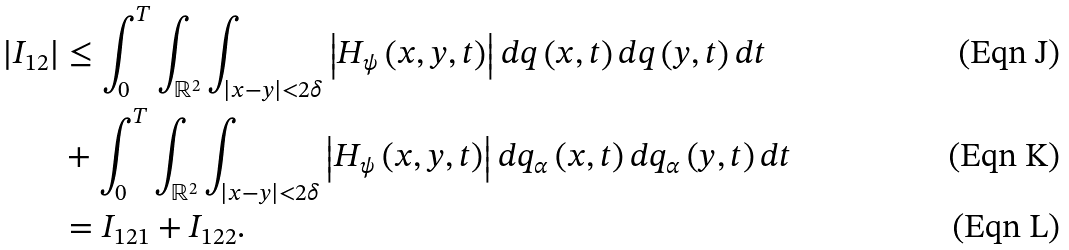Convert formula to latex. <formula><loc_0><loc_0><loc_500><loc_500>\left | I _ { 1 2 } \right | & \leq \int _ { 0 } ^ { T } \int _ { \mathbb { R } ^ { 2 } } \int _ { \left | x - y \right | < 2 \delta } \left | H _ { \psi } \left ( x , y , t \right ) \right | d q \left ( x , t \right ) d q \left ( y , t \right ) d t \\ & + \int _ { 0 } ^ { T } \int _ { \mathbb { R } ^ { 2 } } \int _ { \left | x - y \right | < 2 \delta } \left | H _ { \psi } \left ( x , y , t \right ) \right | d q _ { \alpha } \left ( x , t \right ) d q _ { \alpha } \left ( y , t \right ) d t \\ & = I _ { 1 2 1 } + I _ { 1 2 2 } .</formula> 